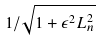Convert formula to latex. <formula><loc_0><loc_0><loc_500><loc_500>1 / \sqrt { 1 + \epsilon ^ { 2 } L _ { n } ^ { 2 } }</formula> 